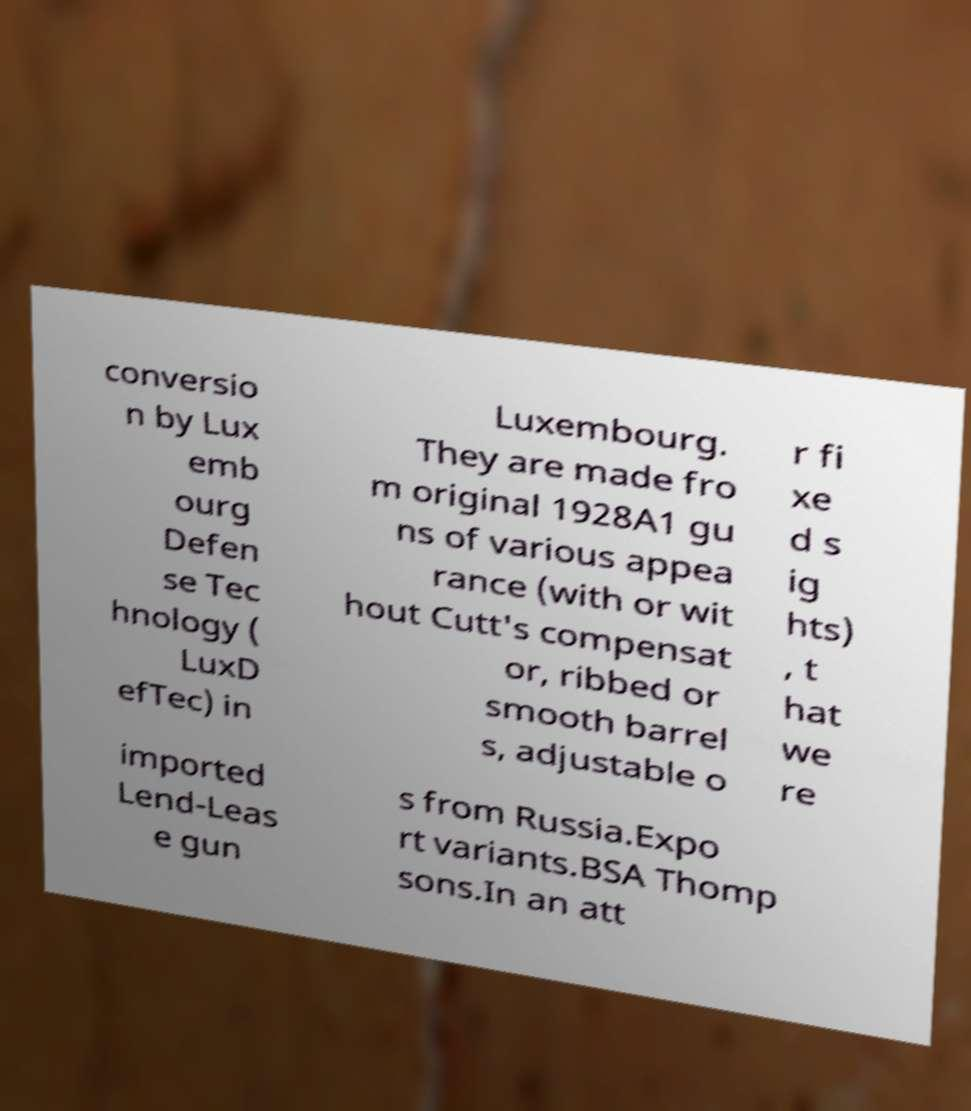Can you read and provide the text displayed in the image?This photo seems to have some interesting text. Can you extract and type it out for me? conversio n by Lux emb ourg Defen se Tec hnology ( LuxD efTec) in Luxembourg. They are made fro m original 1928A1 gu ns of various appea rance (with or wit hout Cutt's compensat or, ribbed or smooth barrel s, adjustable o r fi xe d s ig hts) , t hat we re imported Lend-Leas e gun s from Russia.Expo rt variants.BSA Thomp sons.In an att 